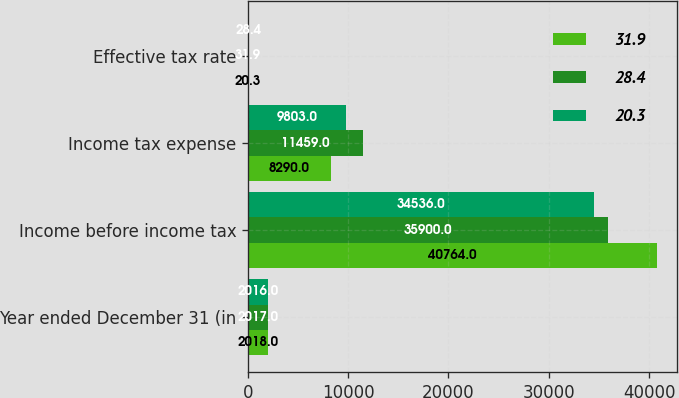Convert chart. <chart><loc_0><loc_0><loc_500><loc_500><stacked_bar_chart><ecel><fcel>Year ended December 31 (in<fcel>Income before income tax<fcel>Income tax expense<fcel>Effective tax rate<nl><fcel>31.9<fcel>2018<fcel>40764<fcel>8290<fcel>20.3<nl><fcel>28.4<fcel>2017<fcel>35900<fcel>11459<fcel>31.9<nl><fcel>20.3<fcel>2016<fcel>34536<fcel>9803<fcel>28.4<nl></chart> 